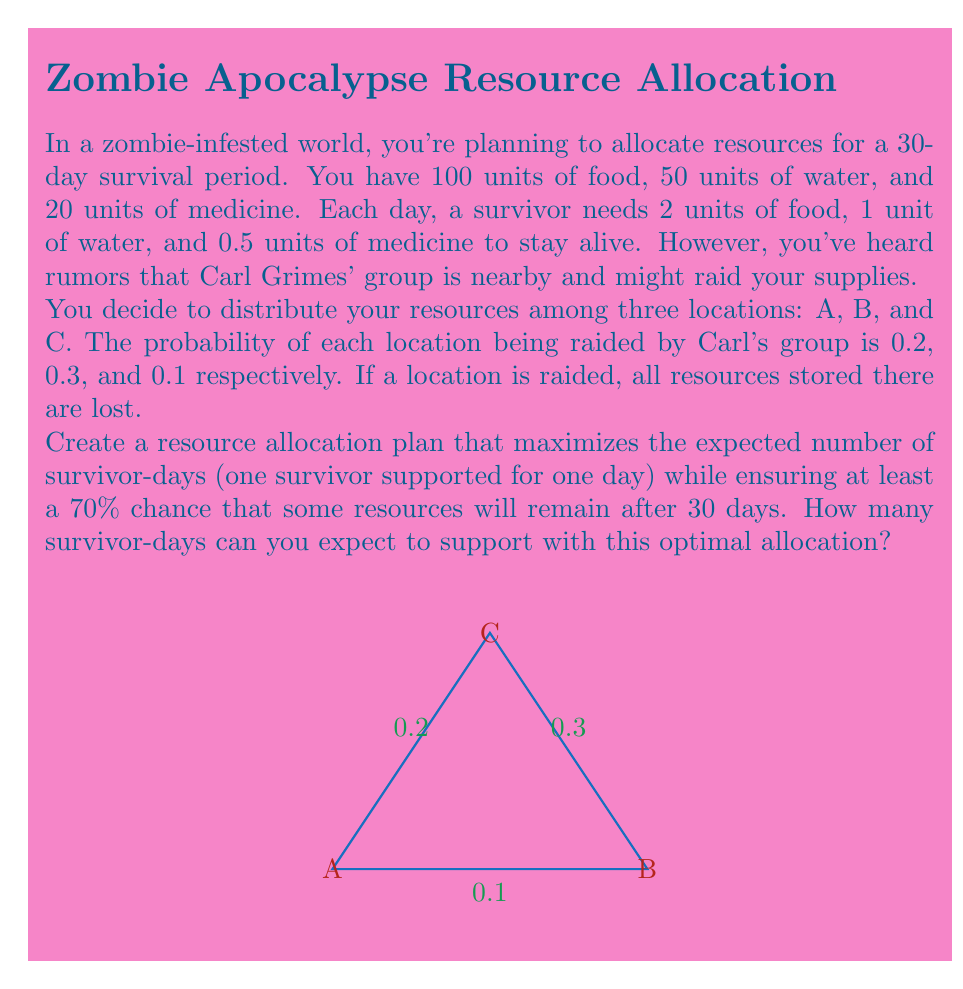What is the answer to this math problem? Let's approach this step-by-step:

1) First, we need to calculate the total resources needed for one survivor for 30 days:
   Food: $30 \times 2 = 60$ units
   Water: $30 \times 1 = 30$ units
   Medicine: $30 \times 0.5 = 15$ units

2) The probability of at least one location not being raided is:
   $1 - (0.2 \times 0.3 \times 0.1) = 0.994$
   This satisfies the 70% requirement.

3) Let $x$, $y$, and $z$ be the number of survivor-days allocated to locations A, B, and C respectively.

4) The expected number of survivor-days is:
   $E = 0.8x + 0.7y + 0.9z$

5) We need to maximize $E$ subject to the following constraints:
   $x + y + z \leq \min(\frac{100}{2}, \frac{50}{1}, \frac{20}{0.5}) = 40$ (total survivor-days)
   $x, y, z \geq 0$

6) This is a linear programming problem. The optimal solution is to allocate all resources to the location with the lowest raid probability, which is C.

7) Therefore, the optimal allocation is:
   $x = 0, y = 0, z = 40$

8) The expected number of survivor-days is:
   $E = 0.8(0) + 0.7(0) + 0.9(40) = 36$
Answer: 36 survivor-days 